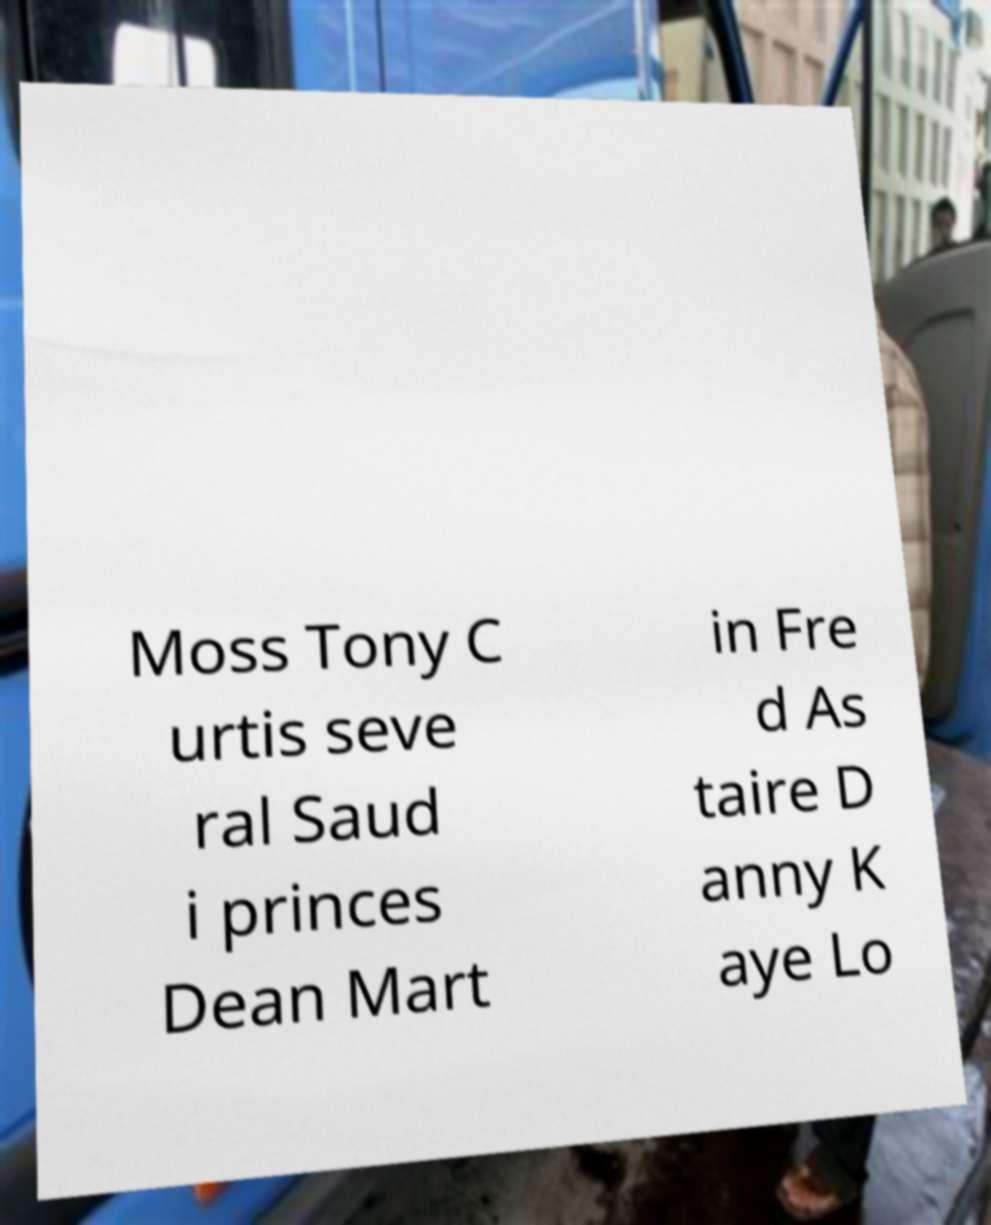Please identify and transcribe the text found in this image. Moss Tony C urtis seve ral Saud i princes Dean Mart in Fre d As taire D anny K aye Lo 